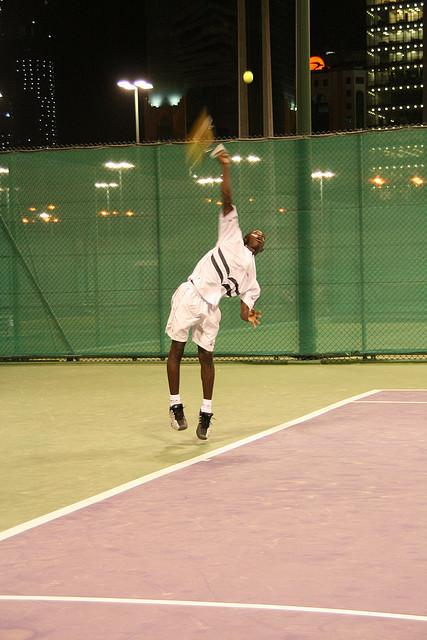What is the man swinging? Please explain your reasoning. tennis racquet. Serena williams made her career using this device. 